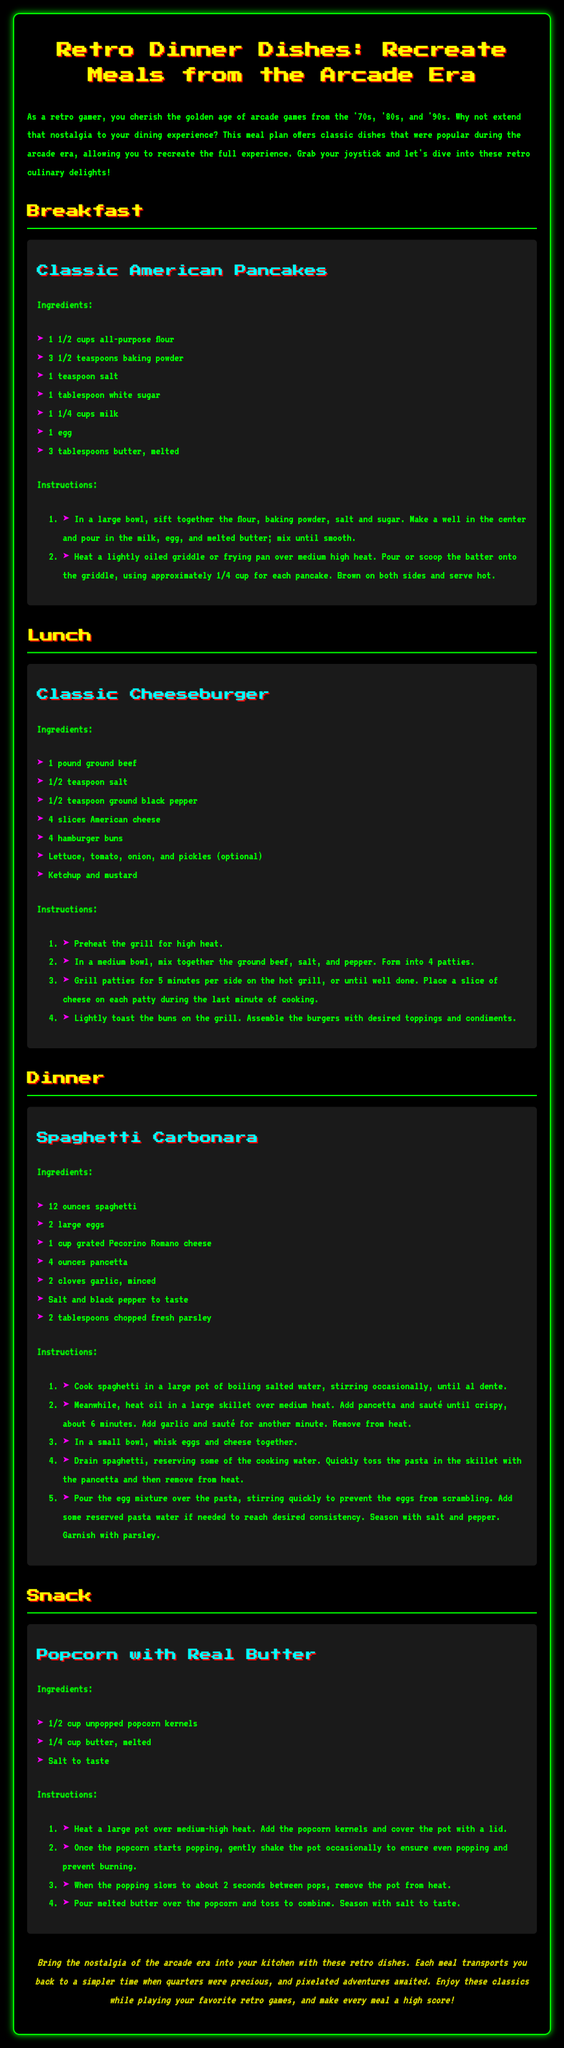What is the title of the meal plan? The title of the meal plan is the main heading at the top of the document.
Answer: Retro Dinner Dishes: Recreate Meals from the Arcade Era How many ingredients are needed for the Classic Cheeseburger? The number of ingredients is listed in the ingredients section for the Classic Cheeseburger.
Answer: 7 What dish is served for lunch? The lunch section lists a specific dish as the main item for that meal break.
Answer: Classic Cheeseburger What is the cooking time for the Spaghetti Carbonara? The instructions for Spaghetti Carbonara include specific cooking times in the preparation steps.
Answer: 6 minutes Which meal includes popcorn? The meal section provides the title of snacks that includes a specific dish for snacking.
Answer: Snack What are the main components of the Classic American Pancakes? The ingredients for Classic American Pancakes show the main components needed to make this dish.
Answer: Flour, baking powder, salt, sugar, milk, egg, butter Which meal plan section has the most detailed instructions? The dinner section provides a more complex recipe, indicating depth in the instructions for a specific dish.
Answer: Dinner What is used to season the popcorn? The instructions for preparing popcorn specify how to season it in the final steps.
Answer: Salt 